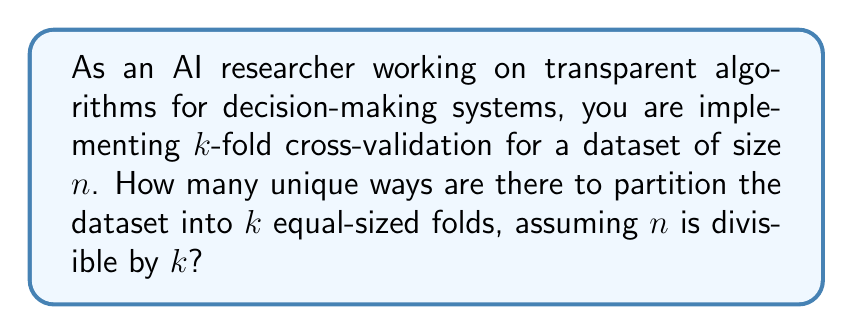Solve this math problem. Let's approach this step-by-step:

1) First, we need to understand what k-fold cross-validation means. In k-fold cross-validation, the dataset is divided into k equal-sized folds.

2) The total number of data points is n, and each fold contains n/k data points.

3) This problem is equivalent to choosing which data points go into each fold. Once we've assigned data points to k-1 folds, the last fold is automatically determined.

4) We can think of this as a sequence of choices:
   - Choose n/k items for the first fold
   - Choose n/k items from the remaining (n - n/k) for the second fold
   - Continue until we've chosen for k-1 folds

5) This is a combination problem. For each fold, we're choosing n/k items from the remaining items.

6) The number of ways to make these choices is:

   $$\binom{n}{n/k} \cdot \binom{n-n/k}{n/k} \cdot \binom{n-2n/k}{n/k} \cdot ... \cdot \binom{n-(k-2)n/k}{n/k}$$

7) This can be simplified to:

   $$\frac{n!}{((n/k)!)^k}$$

8) However, this counts permutations of the folds as different partitions. Since the order of the folds doesn't matter, we need to divide by the number of ways to order k folds, which is k!.

9) Therefore, the final formula is:

   $$\frac{n!}{k! \cdot ((n/k)!)^k}$$

This formula gives the number of unique ways to partition the dataset into k equal-sized folds for cross-validation.
Answer: The number of unique ways to partition a dataset of size n into k equal-sized folds for cross-validation, where n is divisible by k, is:

$$\frac{n!}{k! \cdot ((n/k)!)^k}$$ 